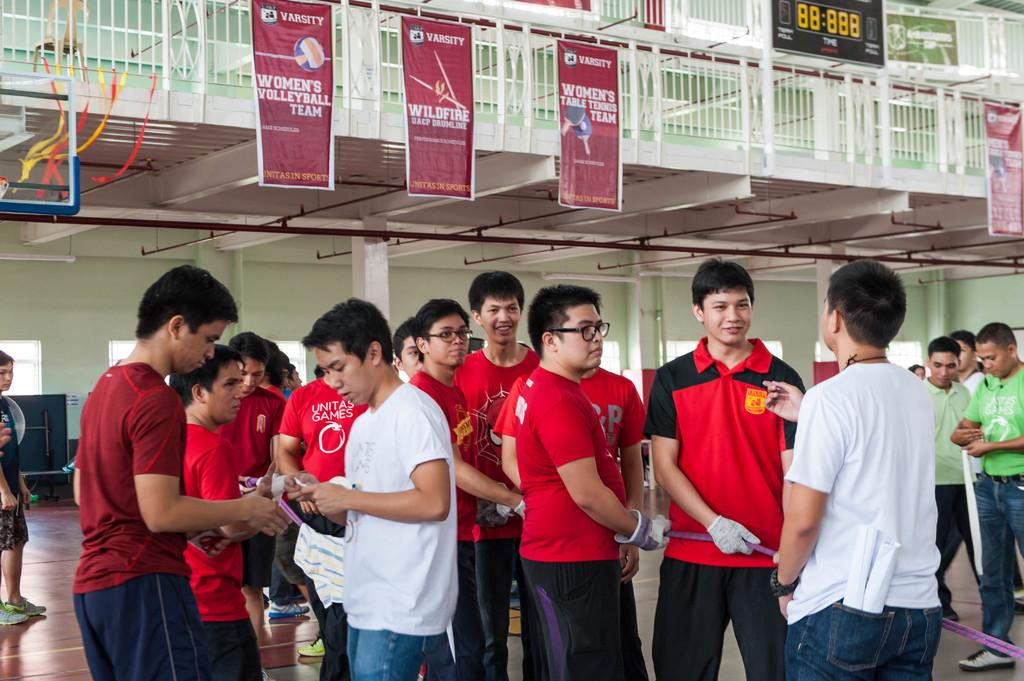What can be seen in the image related to people? There are persons wearing clothes in the image. What is hanging from the balcony in the image? There are banners hanging from the balcony. Where is the screen located in the image? There is a screen in the top right of the image. What type of haircut do the persons have in the image? There is no information about the persons' haircuts in the image. How does the sail affect the image? There is no sail present in the image. 